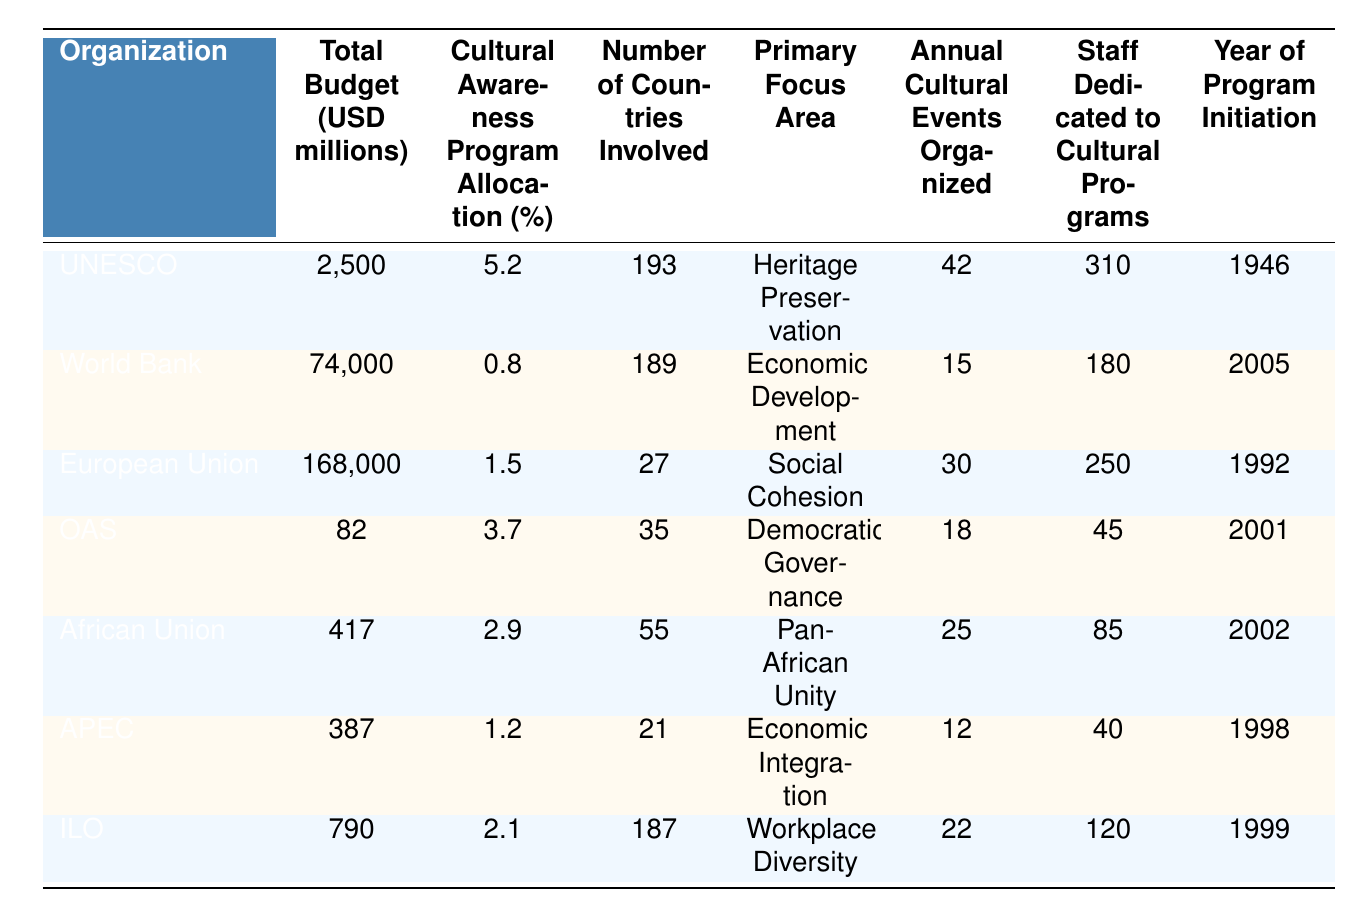What is the total budget of the European Union? The table lists the total budget for each organization, and for the European Union, it is stated as 168,000 million USD.
Answer: 168,000 million USD Which organization has dedicated the highest percentage of its budget to cultural awareness programs? By comparing the "Cultural Awareness Program Allocation (%)" values, UNESCO has the highest allocation at 5.2%.
Answer: UNESCO How many countries are involved in the cultural awareness programs of the International Labour Organization (ILO)? The table shows that the number of countries involved in the ILO's programs is 187.
Answer: 187 What is the average allocation percentage for cultural awareness programs among all listed organizations? The percentages are: 5.2, 0.8, 1.5, 3.7, 2.9, 1.2, and 2.1. Adding these gives 17.4%, and dividing by 7 (the number of organizations) yields an average of 2.49%.
Answer: 2.49% Is the total budget for the World Bank greater than that of the African Union? The total budget for the World Bank is 74,000 million USD, and for the African Union, it is 417 million USD. Since 74,000 is greater than 417, the statement is true.
Answer: Yes Which organization, out of those listed, has the least annual cultural events organized? The annual cultural events organized by each organization are 42, 15, 30, 18, 25, 12, and 22. A comparison shows that APEC has organized the least, with only 12 events.
Answer: APEC If we sum the total budgets of the United Nations Educational, Scientific and Cultural Organization (UNESCO) and the Organization of American States (OAS), what will be the total? UNESCO has a budget of 2,500 million USD and OAS has 82 million USD. Adding these amounts together gives 2,500 + 82 = 2,582 million USD.
Answer: 2,582 million USD What primary focus area does the World Bank prioritize in its cultural awareness programs? The table indicates that the World Bank's primary focus area is "Economic Development."
Answer: Economic Development How many staff members are dedicated to cultural programs in the African Union? The table states that the African Union has 85 staff members dedicated to cultural programs.
Answer: 85 Which organization was a pioneer in initiating its cultural awareness program in 1946? According to the "Year of Program Initiation," UNESCO initiated its program in 1946.
Answer: UNESCO What is the difference in the number of annual cultural events organized between the European Union and the International Labour Organization (ILO)? The European Union organizes 30 events and ILO organizes 22. The difference is 30 - 22 = 8 events.
Answer: 8 events 